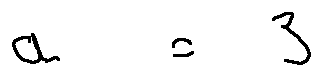Convert formula to latex. <formula><loc_0><loc_0><loc_500><loc_500>a = 3</formula> 